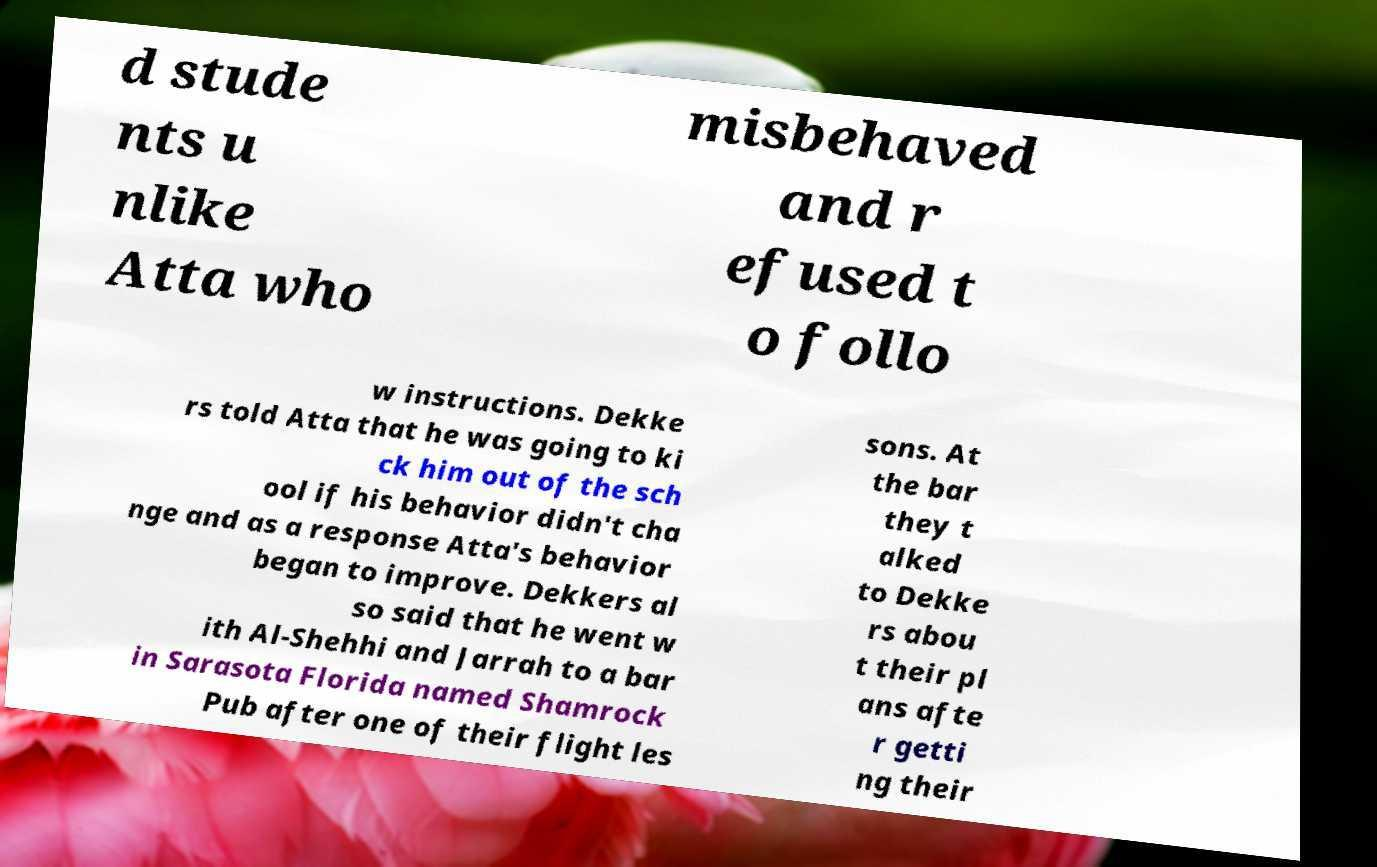Please read and relay the text visible in this image. What does it say? d stude nts u nlike Atta who misbehaved and r efused t o follo w instructions. Dekke rs told Atta that he was going to ki ck him out of the sch ool if his behavior didn't cha nge and as a response Atta's behavior began to improve. Dekkers al so said that he went w ith Al-Shehhi and Jarrah to a bar in Sarasota Florida named Shamrock Pub after one of their flight les sons. At the bar they t alked to Dekke rs abou t their pl ans afte r getti ng their 